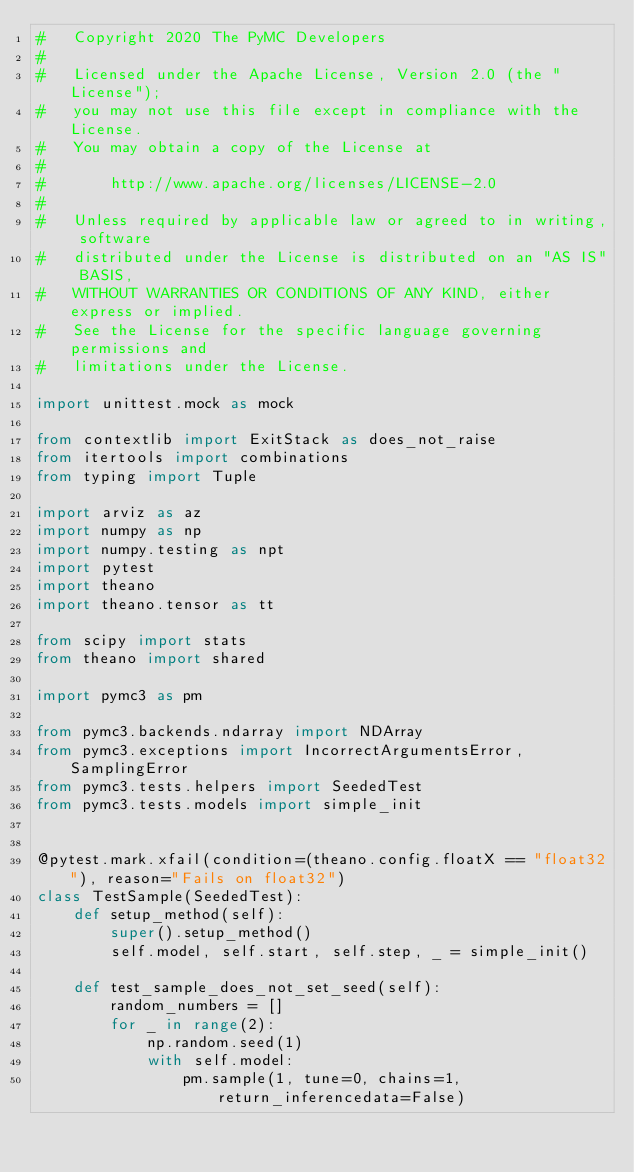<code> <loc_0><loc_0><loc_500><loc_500><_Python_>#   Copyright 2020 The PyMC Developers
#
#   Licensed under the Apache License, Version 2.0 (the "License");
#   you may not use this file except in compliance with the License.
#   You may obtain a copy of the License at
#
#       http://www.apache.org/licenses/LICENSE-2.0
#
#   Unless required by applicable law or agreed to in writing, software
#   distributed under the License is distributed on an "AS IS" BASIS,
#   WITHOUT WARRANTIES OR CONDITIONS OF ANY KIND, either express or implied.
#   See the License for the specific language governing permissions and
#   limitations under the License.

import unittest.mock as mock

from contextlib import ExitStack as does_not_raise
from itertools import combinations
from typing import Tuple

import arviz as az
import numpy as np
import numpy.testing as npt
import pytest
import theano
import theano.tensor as tt

from scipy import stats
from theano import shared

import pymc3 as pm

from pymc3.backends.ndarray import NDArray
from pymc3.exceptions import IncorrectArgumentsError, SamplingError
from pymc3.tests.helpers import SeededTest
from pymc3.tests.models import simple_init


@pytest.mark.xfail(condition=(theano.config.floatX == "float32"), reason="Fails on float32")
class TestSample(SeededTest):
    def setup_method(self):
        super().setup_method()
        self.model, self.start, self.step, _ = simple_init()

    def test_sample_does_not_set_seed(self):
        random_numbers = []
        for _ in range(2):
            np.random.seed(1)
            with self.model:
                pm.sample(1, tune=0, chains=1, return_inferencedata=False)</code> 